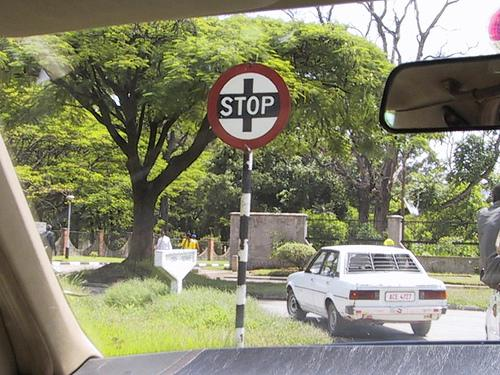Question: where does it say "STOP"?
Choices:
A. On the sign.
B. On the road.
C. On the wall.
D. In the sky.
Answer with the letter. Answer: A Question: what does the sign say?
Choices:
A. Go.
B. Walk.
C. Run.
D. STOP.
Answer with the letter. Answer: D Question: how many letters are on the sign?
Choices:
A. Three.
B. Two.
C. Four.
D. Five.
Answer with the letter. Answer: C Question: what shape is the sign?
Choices:
A. Triangle.
B. Octagon.
C. A circle.
D. Square.
Answer with the letter. Answer: C 